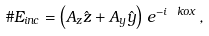<formula> <loc_0><loc_0><loc_500><loc_500>\# E _ { i n c } = \left ( A _ { z } \hat { z } + A _ { y } \hat { y } \right ) \, e ^ { - i \ k o x } \, ,</formula> 